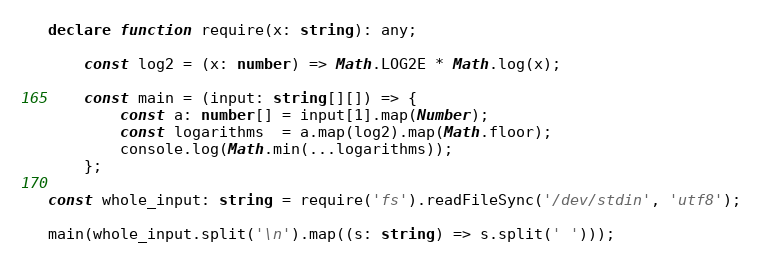<code> <loc_0><loc_0><loc_500><loc_500><_TypeScript_>declare function require(x: string): any;

    const log2 = (x: number) => Math.LOG2E * Math.log(x);

    const main = (input: string[][]) => {
        const a: number[] = input[1].map(Number);
        const logarithms  = a.map(log2).map(Math.floor);
        console.log(Math.min(...logarithms));
    };

const whole_input: string = require('fs').readFileSync('/dev/stdin', 'utf8');

main(whole_input.split('\n').map((s: string) => s.split(' ')));
</code> 